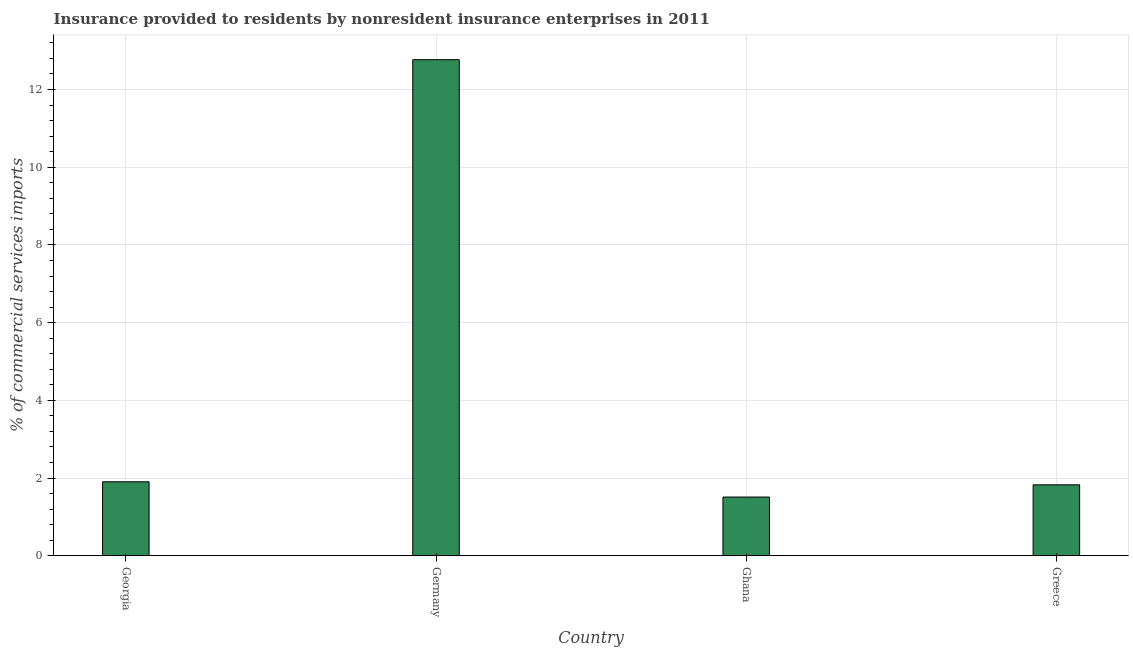Does the graph contain grids?
Offer a very short reply. Yes. What is the title of the graph?
Give a very brief answer. Insurance provided to residents by nonresident insurance enterprises in 2011. What is the label or title of the X-axis?
Provide a succinct answer. Country. What is the label or title of the Y-axis?
Offer a terse response. % of commercial services imports. What is the insurance provided by non-residents in Greece?
Ensure brevity in your answer.  1.83. Across all countries, what is the maximum insurance provided by non-residents?
Offer a terse response. 12.77. Across all countries, what is the minimum insurance provided by non-residents?
Provide a succinct answer. 1.51. In which country was the insurance provided by non-residents maximum?
Offer a terse response. Germany. What is the sum of the insurance provided by non-residents?
Provide a succinct answer. 18.01. What is the difference between the insurance provided by non-residents in Georgia and Ghana?
Offer a very short reply. 0.39. What is the average insurance provided by non-residents per country?
Your answer should be very brief. 4.5. What is the median insurance provided by non-residents?
Keep it short and to the point. 1.87. In how many countries, is the insurance provided by non-residents greater than 8.8 %?
Your response must be concise. 1. What is the ratio of the insurance provided by non-residents in Georgia to that in Greece?
Make the answer very short. 1.04. Is the difference between the insurance provided by non-residents in Georgia and Ghana greater than the difference between any two countries?
Provide a succinct answer. No. What is the difference between the highest and the second highest insurance provided by non-residents?
Keep it short and to the point. 10.86. Is the sum of the insurance provided by non-residents in Germany and Greece greater than the maximum insurance provided by non-residents across all countries?
Offer a very short reply. Yes. What is the difference between the highest and the lowest insurance provided by non-residents?
Keep it short and to the point. 11.26. How many bars are there?
Provide a short and direct response. 4. Are all the bars in the graph horizontal?
Provide a succinct answer. No. How many countries are there in the graph?
Ensure brevity in your answer.  4. What is the difference between two consecutive major ticks on the Y-axis?
Give a very brief answer. 2. Are the values on the major ticks of Y-axis written in scientific E-notation?
Your answer should be compact. No. What is the % of commercial services imports in Georgia?
Provide a short and direct response. 1.9. What is the % of commercial services imports in Germany?
Give a very brief answer. 12.77. What is the % of commercial services imports of Ghana?
Make the answer very short. 1.51. What is the % of commercial services imports in Greece?
Offer a terse response. 1.83. What is the difference between the % of commercial services imports in Georgia and Germany?
Provide a short and direct response. -10.86. What is the difference between the % of commercial services imports in Georgia and Ghana?
Ensure brevity in your answer.  0.39. What is the difference between the % of commercial services imports in Georgia and Greece?
Provide a short and direct response. 0.08. What is the difference between the % of commercial services imports in Germany and Ghana?
Your answer should be compact. 11.26. What is the difference between the % of commercial services imports in Germany and Greece?
Make the answer very short. 10.94. What is the difference between the % of commercial services imports in Ghana and Greece?
Keep it short and to the point. -0.32. What is the ratio of the % of commercial services imports in Georgia to that in Germany?
Ensure brevity in your answer.  0.15. What is the ratio of the % of commercial services imports in Georgia to that in Ghana?
Ensure brevity in your answer.  1.26. What is the ratio of the % of commercial services imports in Georgia to that in Greece?
Keep it short and to the point. 1.04. What is the ratio of the % of commercial services imports in Germany to that in Ghana?
Keep it short and to the point. 8.45. What is the ratio of the % of commercial services imports in Germany to that in Greece?
Give a very brief answer. 6.99. What is the ratio of the % of commercial services imports in Ghana to that in Greece?
Provide a succinct answer. 0.83. 